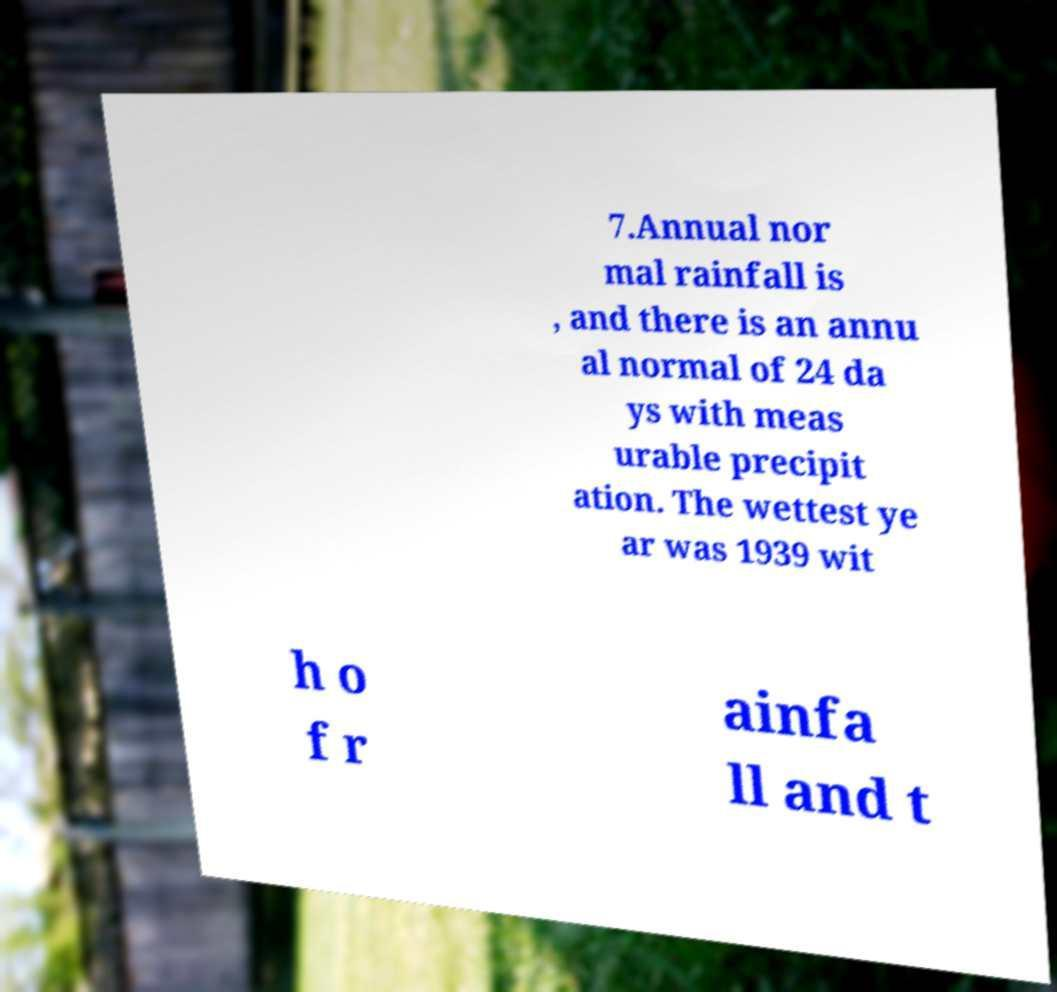There's text embedded in this image that I need extracted. Can you transcribe it verbatim? 7.Annual nor mal rainfall is , and there is an annu al normal of 24 da ys with meas urable precipit ation. The wettest ye ar was 1939 wit h o f r ainfa ll and t 